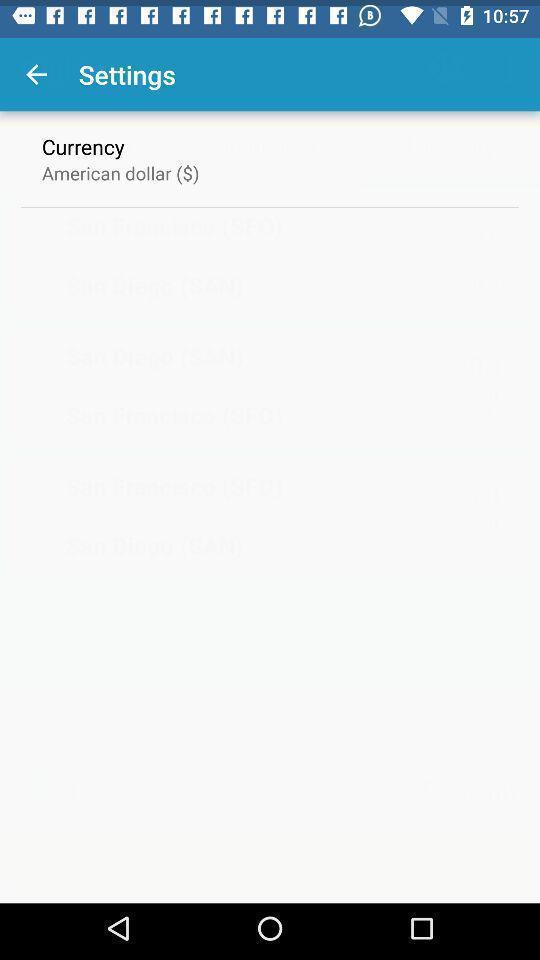Provide a detailed account of this screenshot. Settings page showing the currency. 